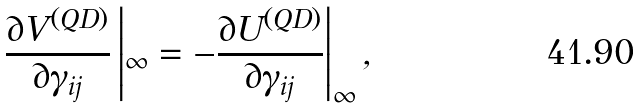<formula> <loc_0><loc_0><loc_500><loc_500>\frac { \partial V ^ { ( Q D ) } } { \partial \gamma _ { i j } } \left | _ { \infty } = - \frac { \partial U ^ { ( Q D ) } } { \partial \gamma _ { i j } } \right | _ { \infty } ,</formula> 